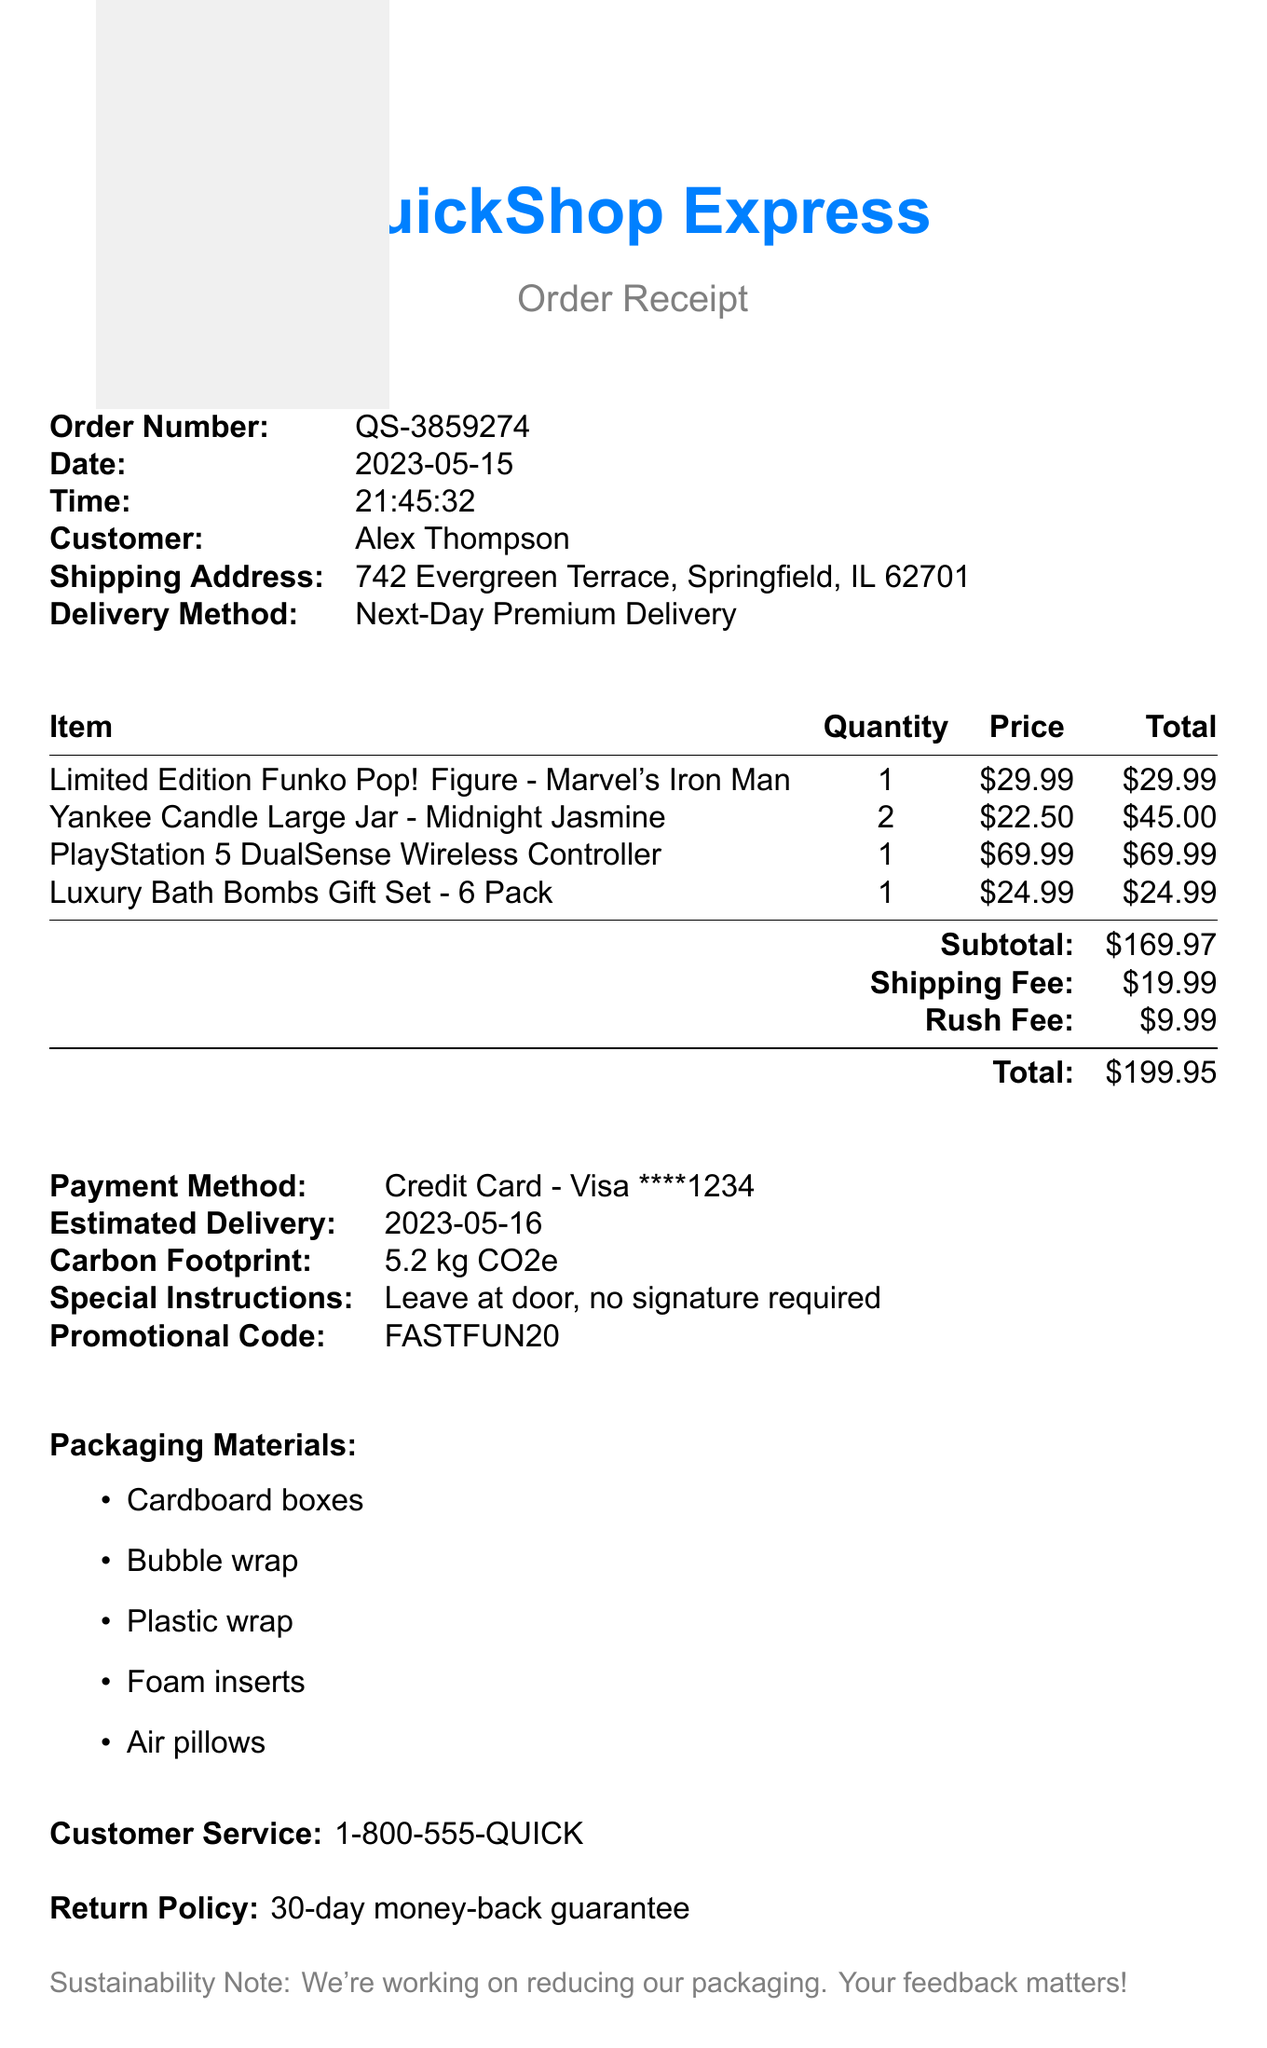What is the store name? The store name is specified at the beginning of the receipt.
Answer: QuickShop Express What is the order number? The order number is listed directly under the store name.
Answer: QS-3859274 What is the total amount charged? The total amount charged is found at the bottom of the items section.
Answer: $199.95 What is the delivery method? The delivery method is described in the order details.
Answer: Next-Day Premium Delivery How many items were ordered? The number of items can be counted from the list provided in the receipt.
Answer: 5 What is the carbon footprint of this order? The carbon footprint is provided near the payment method section.
Answer: 5.2 kg CO2e What is the return policy? The return policy is mentioned toward the end of the receipt.
Answer: 30-day money-back guarantee What are the packaging materials used? The packaging materials are listed under a specific section.
Answer: Cardboard boxes, Bubble wrap, Plastic wrap, Foam inserts, Air pillows What is the estimated delivery date? The estimated delivery date is found in the shipping information.
Answer: 2023-05-16 What promotional code was used? The promotional code is included in the order details.
Answer: FASTFUN20 